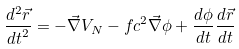<formula> <loc_0><loc_0><loc_500><loc_500>\frac { d ^ { 2 } \vec { r } } { { d t } ^ { 2 } } = - \vec { \nabla } V _ { N } - f c ^ { 2 } \vec { \nabla } { \phi } + \frac { d { \phi } } { d t } \frac { d \vec { r } } { d t }</formula> 